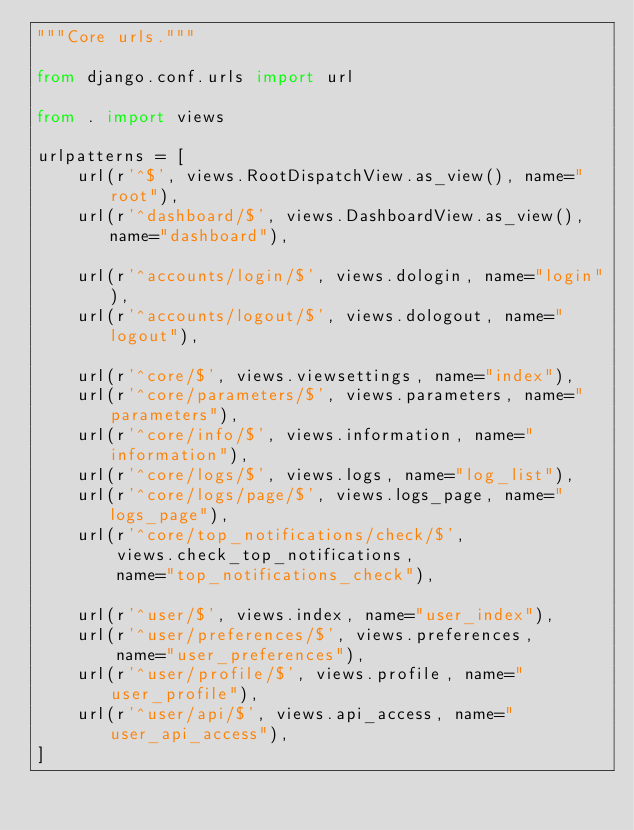Convert code to text. <code><loc_0><loc_0><loc_500><loc_500><_Python_>"""Core urls."""

from django.conf.urls import url

from . import views

urlpatterns = [
    url(r'^$', views.RootDispatchView.as_view(), name="root"),
    url(r'^dashboard/$', views.DashboardView.as_view(), name="dashboard"),

    url(r'^accounts/login/$', views.dologin, name="login"),
    url(r'^accounts/logout/$', views.dologout, name="logout"),

    url(r'^core/$', views.viewsettings, name="index"),
    url(r'^core/parameters/$', views.parameters, name="parameters"),
    url(r'^core/info/$', views.information, name="information"),
    url(r'^core/logs/$', views.logs, name="log_list"),
    url(r'^core/logs/page/$', views.logs_page, name="logs_page"),
    url(r'^core/top_notifications/check/$',
        views.check_top_notifications,
        name="top_notifications_check"),

    url(r'^user/$', views.index, name="user_index"),
    url(r'^user/preferences/$', views.preferences,
        name="user_preferences"),
    url(r'^user/profile/$', views.profile, name="user_profile"),
    url(r'^user/api/$', views.api_access, name="user_api_access"),
]
</code> 